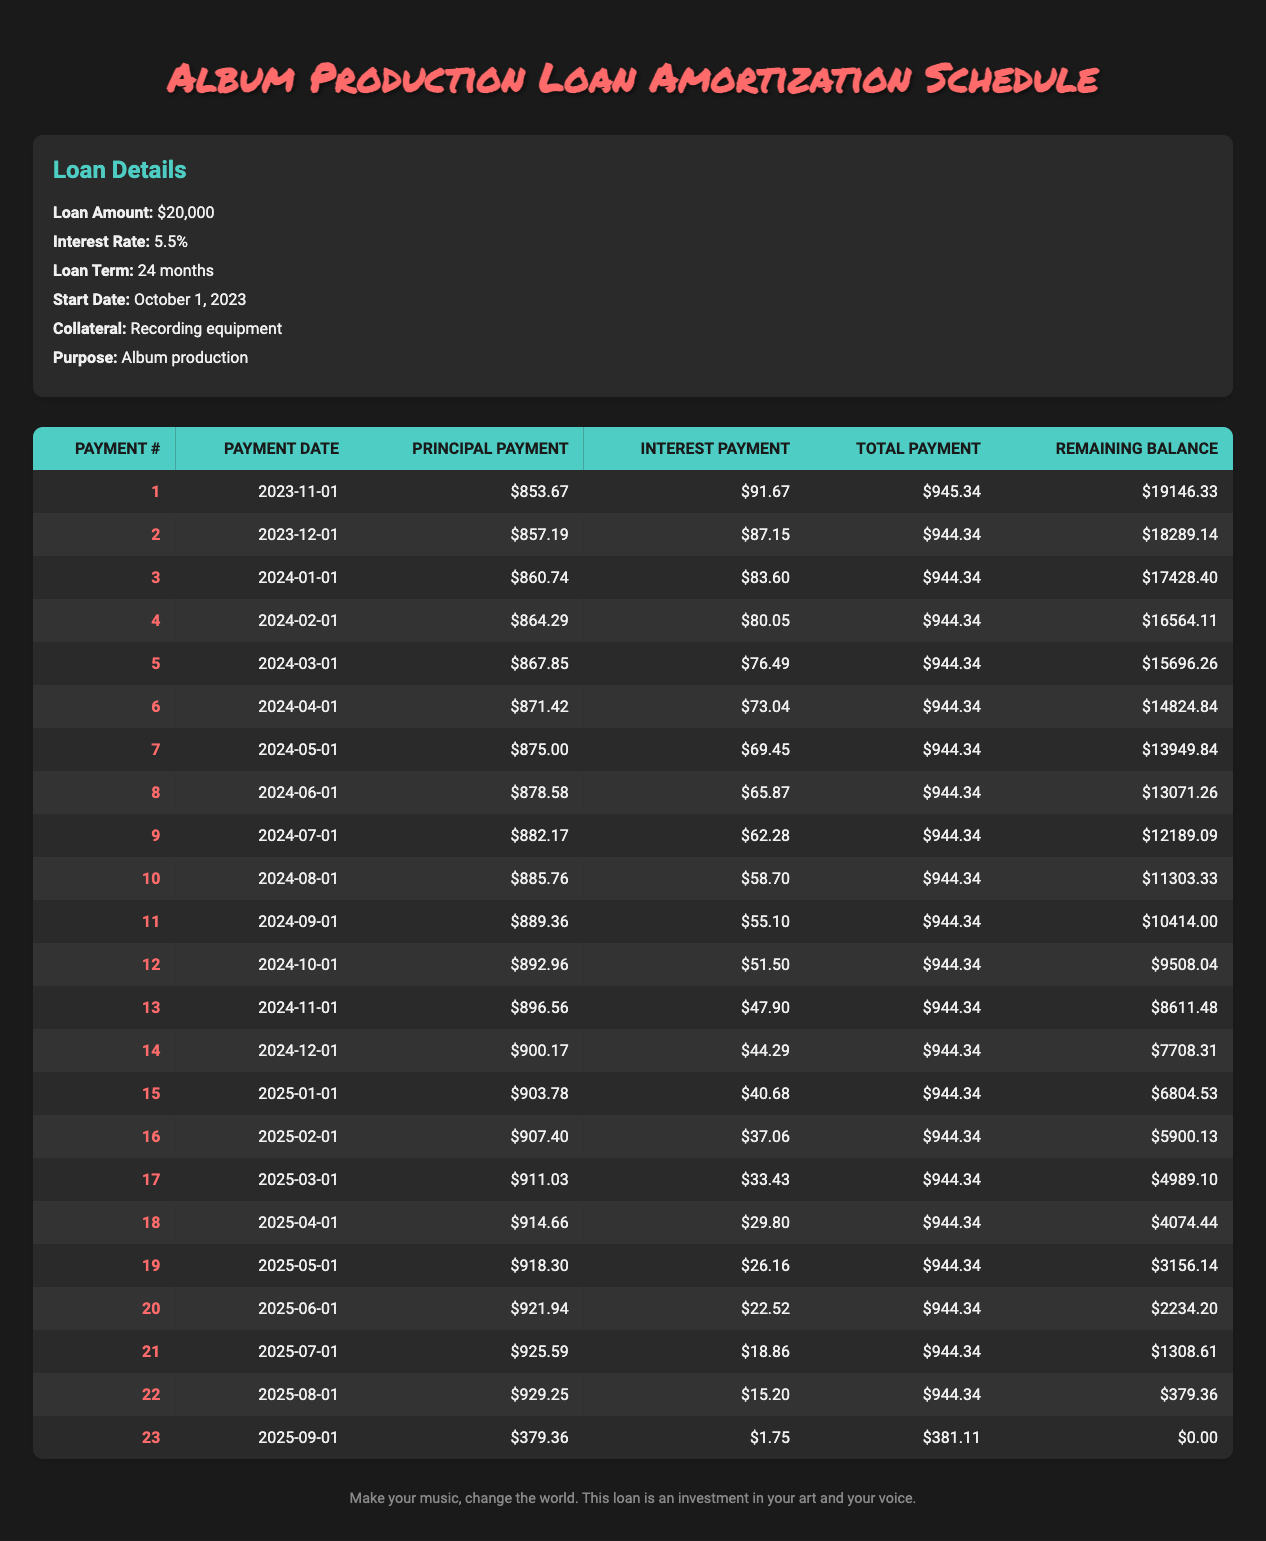What is the total amount paid in interest over the loan term? To find the total interest paid, we sum the interest payments for all the months. This is calculated as follows: 91.67 + 87.15 + 83.60 + 80.05 + 76.49 + 73.04 + 69.45 + 65.87 + 62.28 + 58.70 + 55.10 + 51.50 + 47.90 + 44.29 + 40.68 + 37.06 + 33.43 + 29.80 + 26.16 + 22.52 + 18.86 + 15.20 + 1.75 = 648.00.
Answer: 648.00 What is the remaining balance after the 12th payment? The remaining balance after the 12th payment is listed in the table under "Remaining Balance" for payment number 12, which is 9508.04.
Answer: 9508.04 Did the principal payment increase in the 3rd month compared to the 2nd month? The principal payment in the 3rd month is 860.74 and in the 2nd month is 857.19. Since 860.74 > 857.19, it is true that the principal payment increased.
Answer: Yes How much was the total payment for the 23rd payment? The total payment for the 23rd payment is noted in the "Total Payment" column. It is 381.11.
Answer: 381.11 What was the average principal payment made across the entire loan term? To find the average principal payment, we first sum the principal payments: (853.67 + 857.19 + ... + 379.36) = 19607.29, which when divided by 23 (the number of payments) gives us an average of 853.76 approximately. The step is dividing the total principal payments by the number of payments (19607.29 / 23).
Answer: 853.76 What was the highest total payment made in one month? We check the "Total Payment" column to compare values and find that the maximum total payment is for the first payment, which is 945.34.
Answer: 945.34 Is the total amount for the 15th payment greater than the total amount for the 10th payment? The total payment for the 15th is 944.34, and for the 10th payment it is also 944.34. Since both are equal, the answer is no.
Answer: No How many months did it take to pay off more than $900 in principal? By analyzing the "Principal Payment" column, from payment 1 to payment 15, we find that the principal payments for each month before the 15th all exceed $900. Only payment 23 had a lower principal payment, thus it took 15 months to pay off more than $900 in principal.
Answer: 15 months 